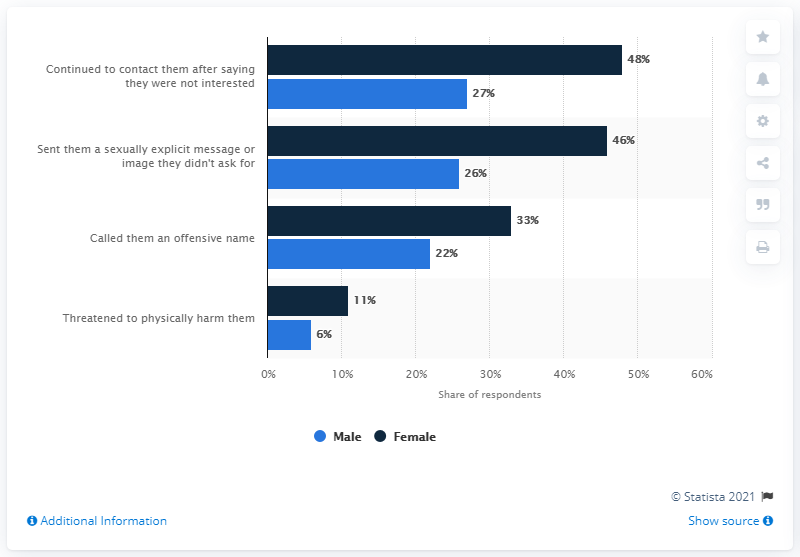Highlight a few significant elements in this photo. The naval bars represent the rank of a female sailor in the military. The least amount of gender difference in exhibiting negative behavior is shown by threatening to physically harm someone. 